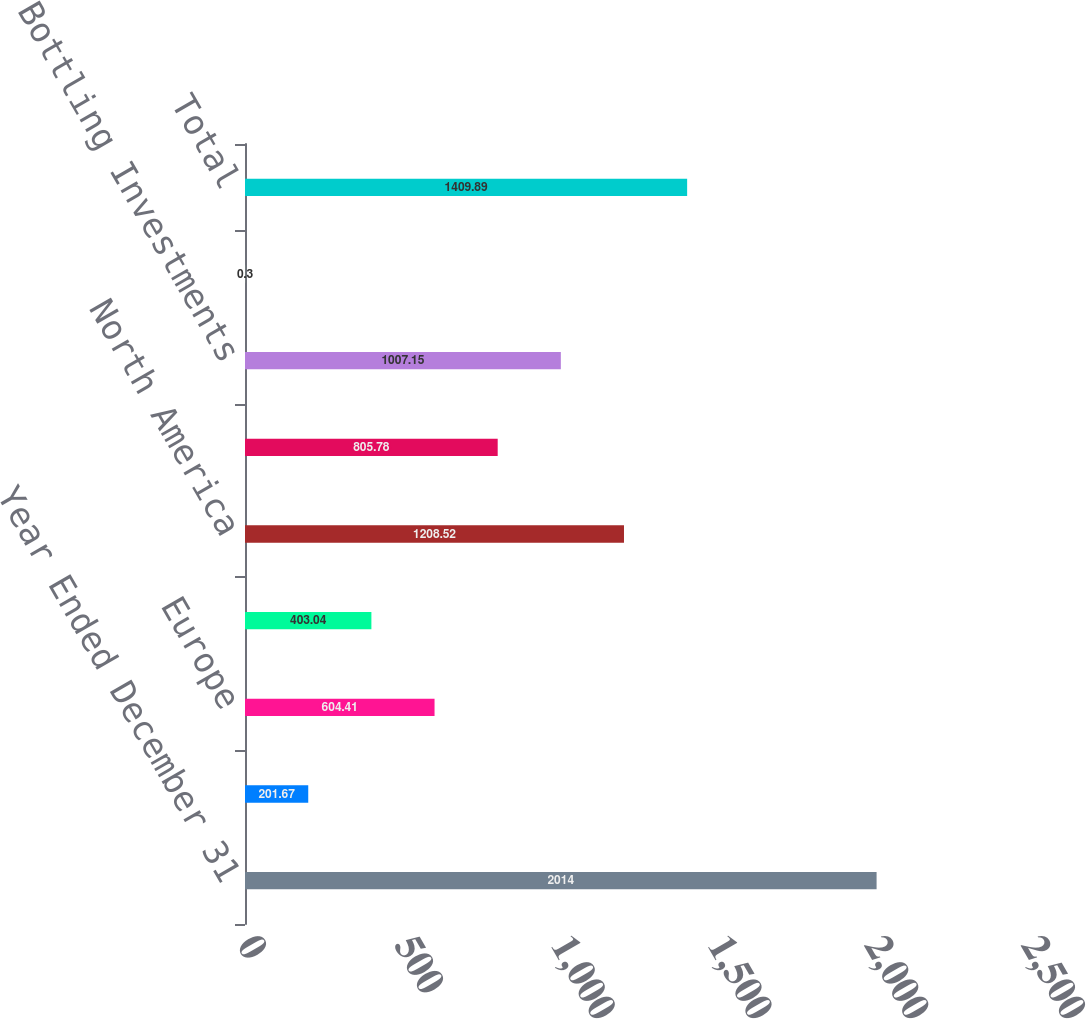<chart> <loc_0><loc_0><loc_500><loc_500><bar_chart><fcel>Year Ended December 31<fcel>Eurasia & Africa<fcel>Europe<fcel>Latin America<fcel>North America<fcel>Asia Pacific<fcel>Bottling Investments<fcel>Corporate<fcel>Total<nl><fcel>2014<fcel>201.67<fcel>604.41<fcel>403.04<fcel>1208.52<fcel>805.78<fcel>1007.15<fcel>0.3<fcel>1409.89<nl></chart> 